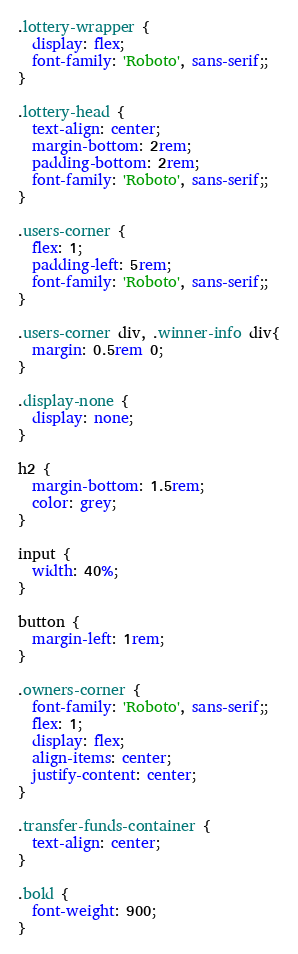Convert code to text. <code><loc_0><loc_0><loc_500><loc_500><_CSS_>.lottery-wrapper {
  display: flex;
  font-family: 'Roboto', sans-serif;;
}

.lottery-head {
  text-align: center;
  margin-bottom: 2rem;
  padding-bottom: 2rem;
  font-family: 'Roboto', sans-serif;;
}

.users-corner {
  flex: 1;
  padding-left: 5rem;
  font-family: 'Roboto', sans-serif;;
}

.users-corner div, .winner-info div{
  margin: 0.5rem 0;
}

.display-none {
  display: none;
}

h2 {
  margin-bottom: 1.5rem;
  color: grey;
}

input {
  width: 40%;
}

button {
  margin-left: 1rem;
}

.owners-corner {
  font-family: 'Roboto', sans-serif;;
  flex: 1;
  display: flex;
  align-items: center;
  justify-content: center;
}

.transfer-funds-container {
  text-align: center;
}

.bold {
  font-weight: 900;
}
</code> 